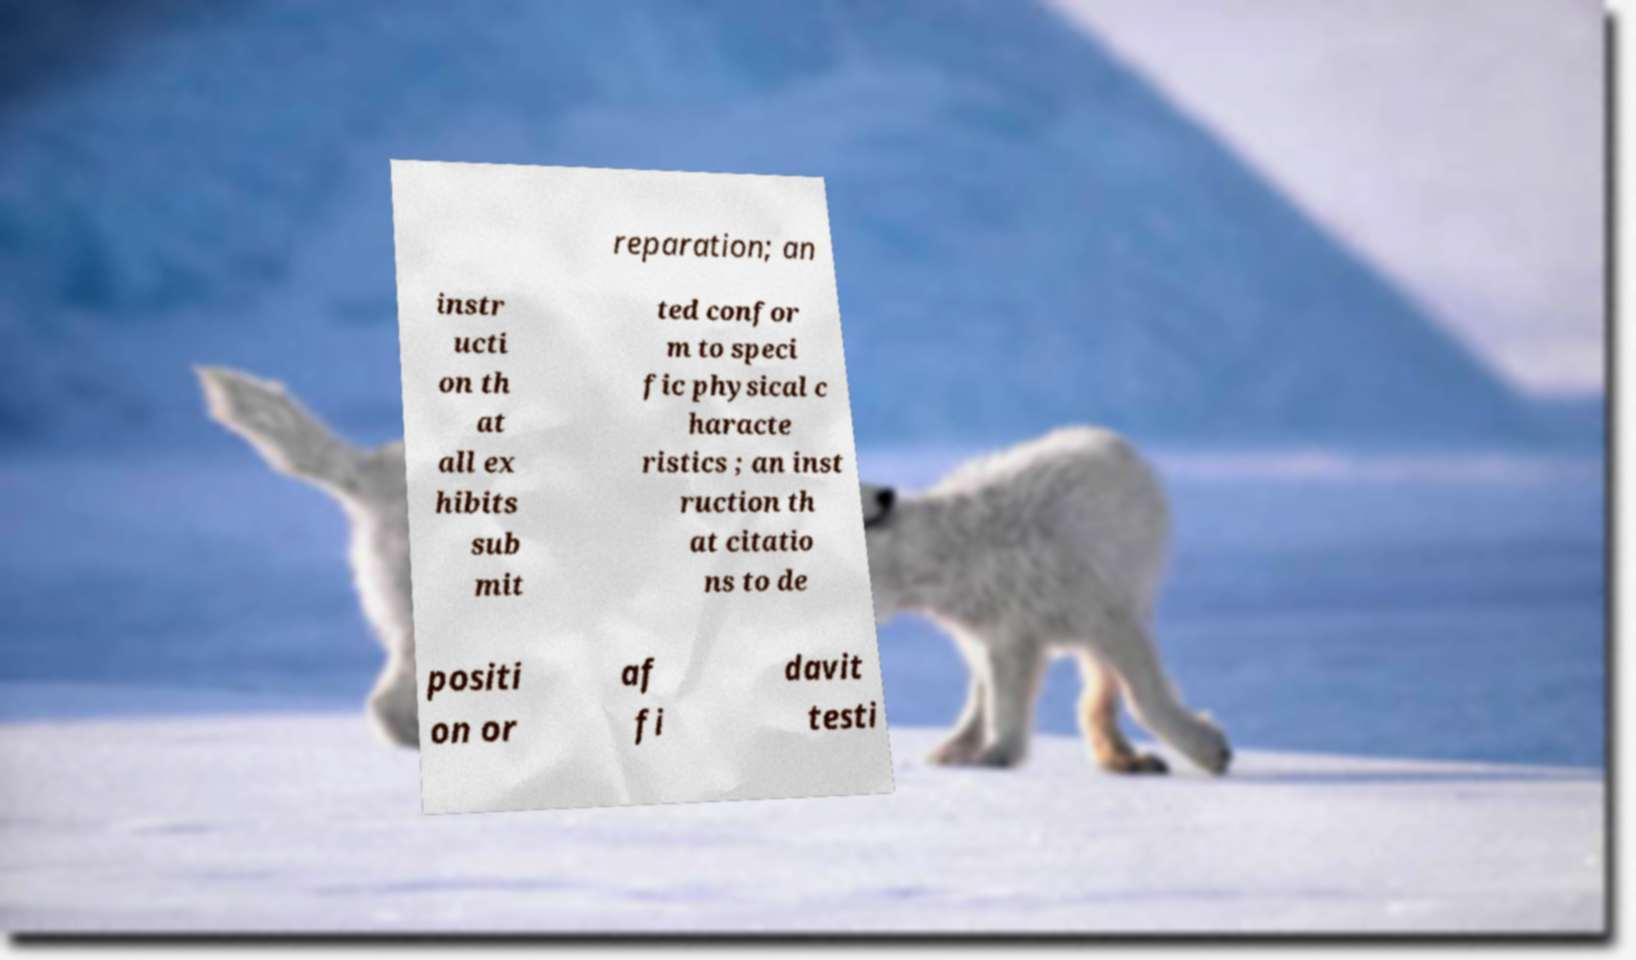Please identify and transcribe the text found in this image. reparation; an instr ucti on th at all ex hibits sub mit ted confor m to speci fic physical c haracte ristics ; an inst ruction th at citatio ns to de positi on or af fi davit testi 